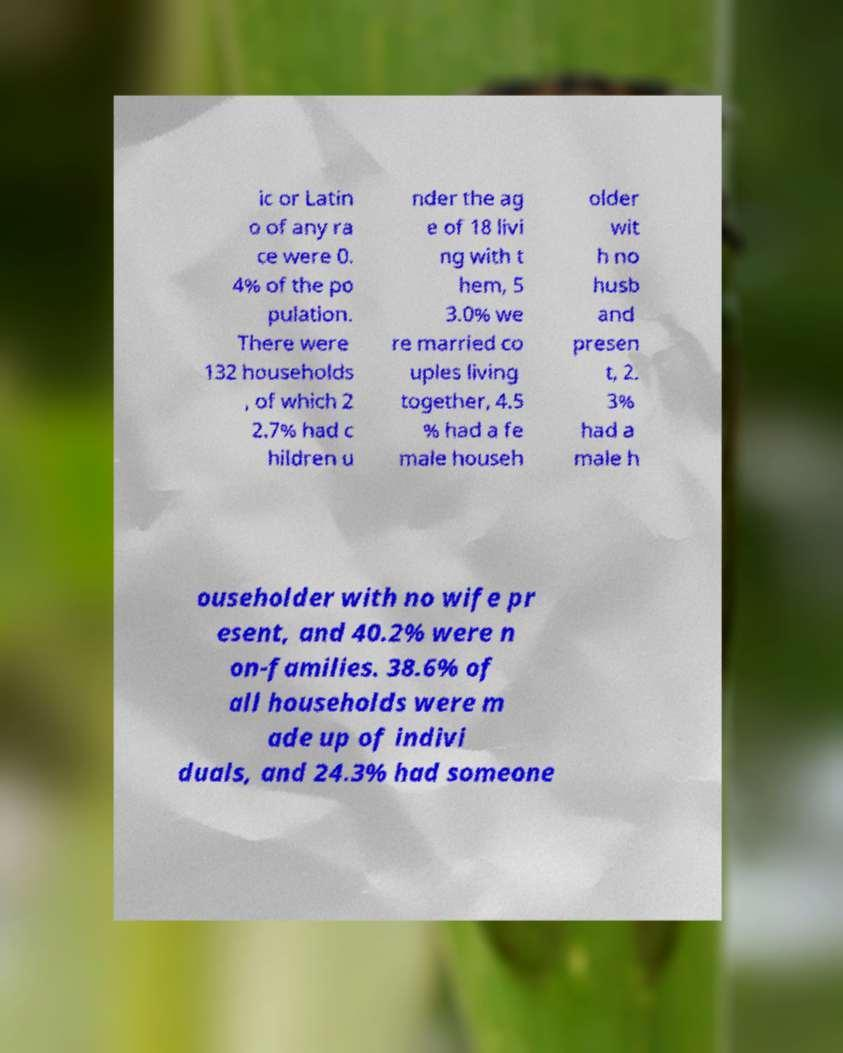Could you extract and type out the text from this image? ic or Latin o of any ra ce were 0. 4% of the po pulation. There were 132 households , of which 2 2.7% had c hildren u nder the ag e of 18 livi ng with t hem, 5 3.0% we re married co uples living together, 4.5 % had a fe male househ older wit h no husb and presen t, 2. 3% had a male h ouseholder with no wife pr esent, and 40.2% were n on-families. 38.6% of all households were m ade up of indivi duals, and 24.3% had someone 